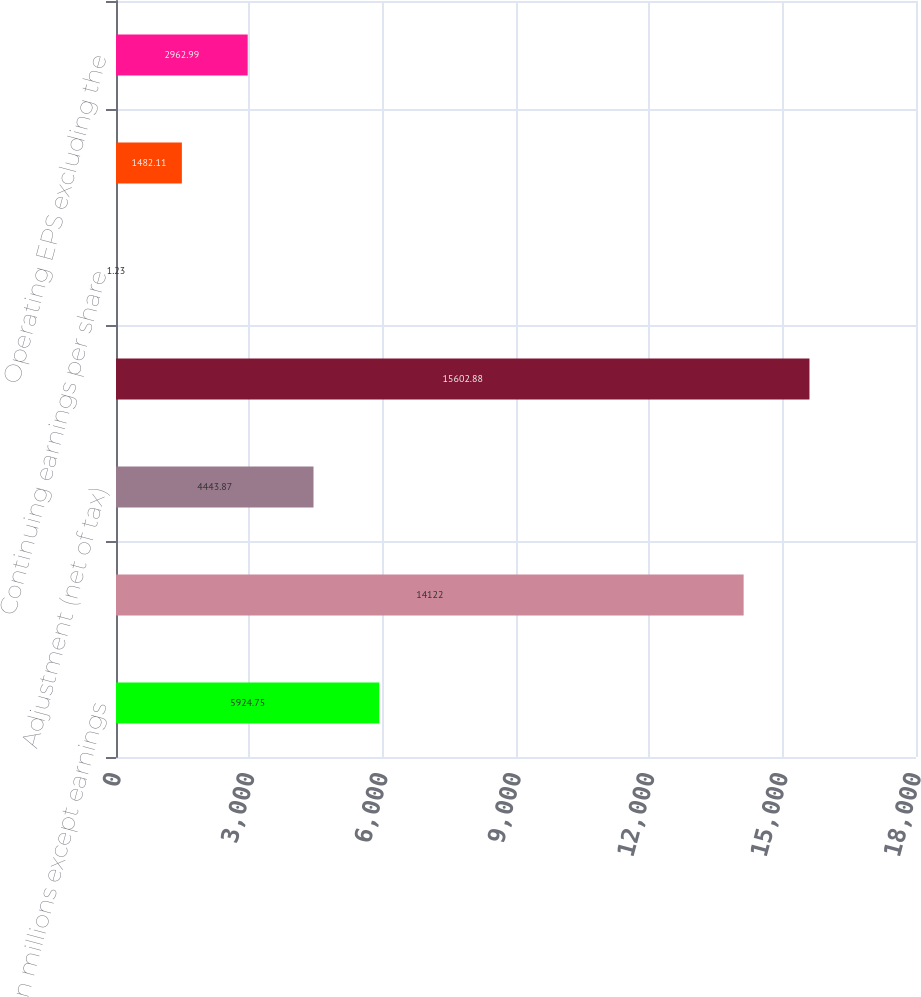Convert chart to OTSL. <chart><loc_0><loc_0><loc_500><loc_500><bar_chart><fcel>(In millions except earnings<fcel>Earnings from continuing<fcel>Adjustment (net of tax)<fcel>Operating earnings<fcel>Continuing earnings per share<fcel>Operating earnings per share<fcel>Operating EPS excluding the<nl><fcel>5924.75<fcel>14122<fcel>4443.87<fcel>15602.9<fcel>1.23<fcel>1482.11<fcel>2962.99<nl></chart> 